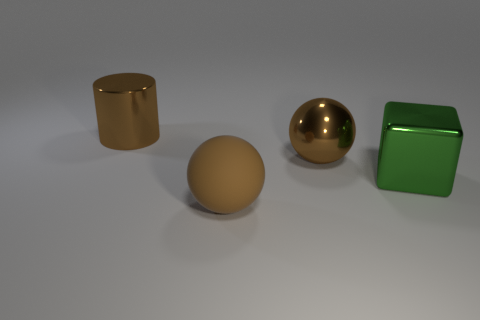How many brown balls must be subtracted to get 1 brown balls? 1 Add 2 balls. How many objects exist? 6 Subtract all cylinders. How many objects are left? 3 Subtract 0 purple cubes. How many objects are left? 4 Subtract all spheres. Subtract all large brown rubber things. How many objects are left? 1 Add 1 large green metal things. How many large green metal things are left? 2 Add 3 small purple things. How many small purple things exist? 3 